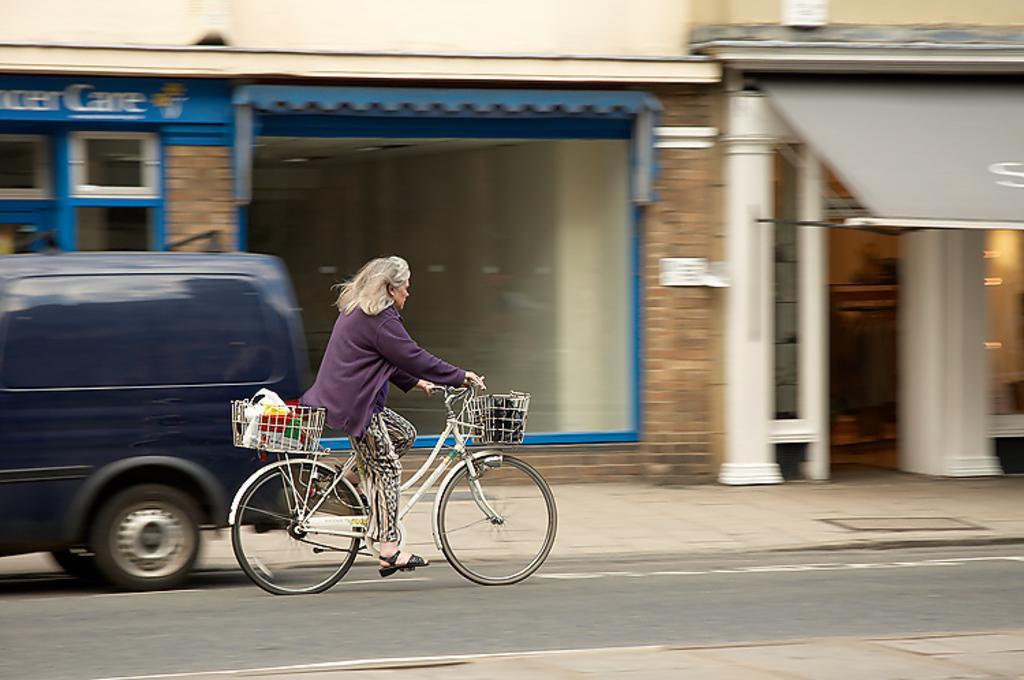Could you give a brief overview of what you see in this image? There is a person who is riding a bicycle. This is road and there is a vehicle. Here we can see a building and this is wall. 